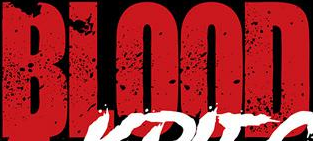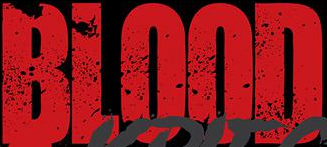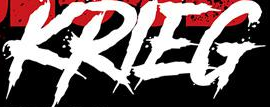What words can you see in these images in sequence, separated by a semicolon? BLOOD; BLOOD; KRIEG 